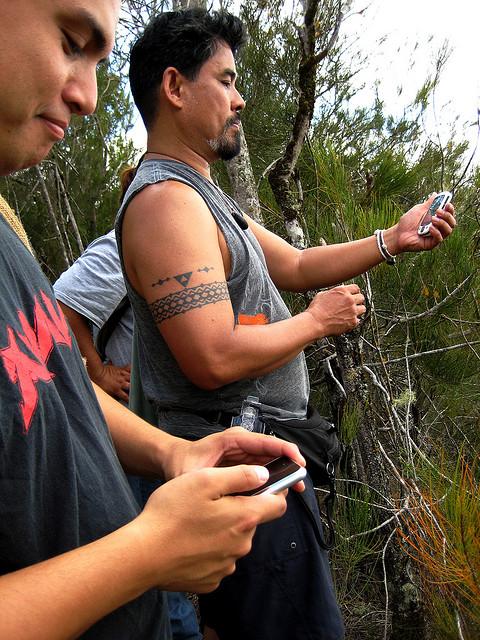What do the men have in their hands?
Short answer required. Cell phones. What is the man wearing on his left wrist?
Quick response, please. Bracelet. What is in the arms of the man with a beard?
Keep it brief. Cell phone. Are these people Kenyans?
Be succinct. No. 